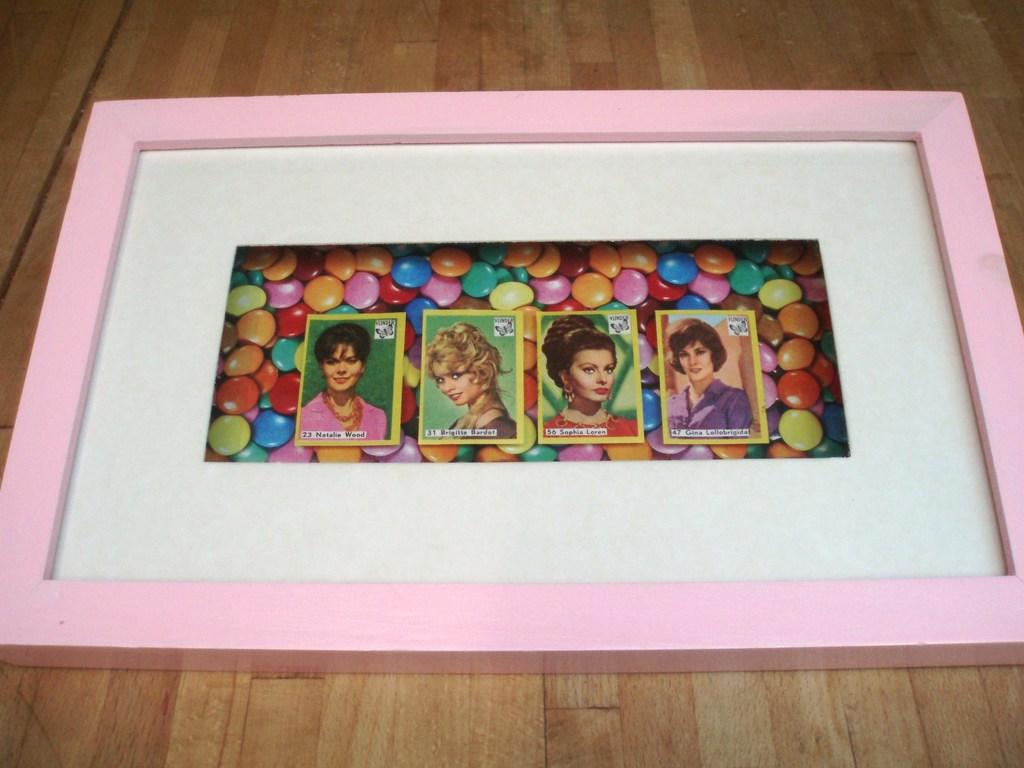What is on the table in the image? There is a frame on the table in the image. What is depicted within the frame? The frame contains pictures of gems and pictures of persons. Are there any toys visible in the image? No, there are no toys present in the image. Can you see any waves in the image? No, there are no waves present in the image. 